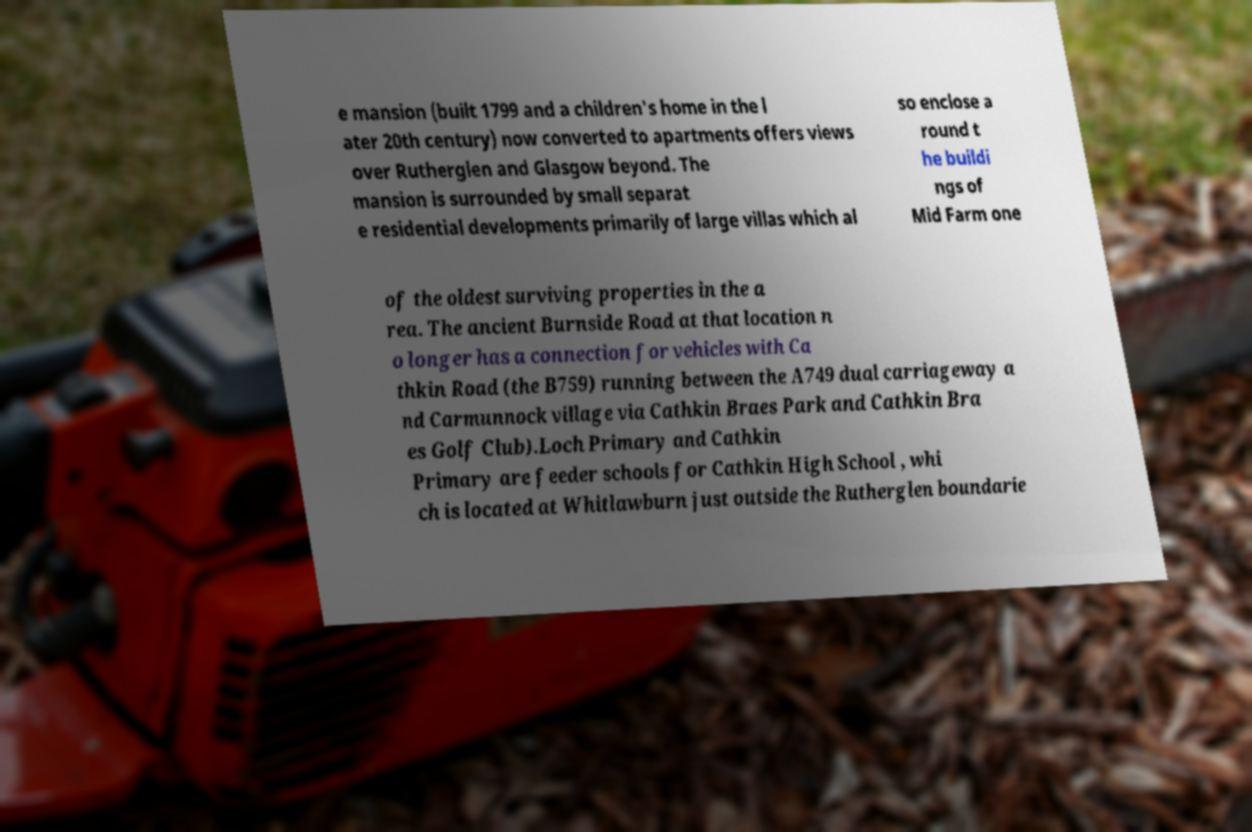There's text embedded in this image that I need extracted. Can you transcribe it verbatim? e mansion (built 1799 and a children's home in the l ater 20th century) now converted to apartments offers views over Rutherglen and Glasgow beyond. The mansion is surrounded by small separat e residential developments primarily of large villas which al so enclose a round t he buildi ngs of Mid Farm one of the oldest surviving properties in the a rea. The ancient Burnside Road at that location n o longer has a connection for vehicles with Ca thkin Road (the B759) running between the A749 dual carriageway a nd Carmunnock village via Cathkin Braes Park and Cathkin Bra es Golf Club).Loch Primary and Cathkin Primary are feeder schools for Cathkin High School , whi ch is located at Whitlawburn just outside the Rutherglen boundarie 